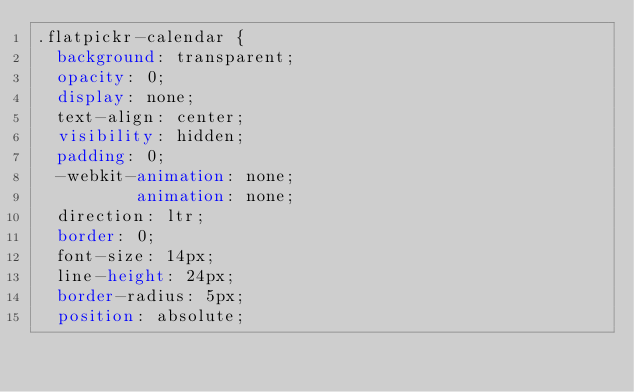<code> <loc_0><loc_0><loc_500><loc_500><_CSS_>.flatpickr-calendar {
  background: transparent;
  opacity: 0;
  display: none;
  text-align: center;
  visibility: hidden;
  padding: 0;
  -webkit-animation: none;
          animation: none;
  direction: ltr;
  border: 0;
  font-size: 14px;
  line-height: 24px;
  border-radius: 5px;
  position: absolute;</code> 